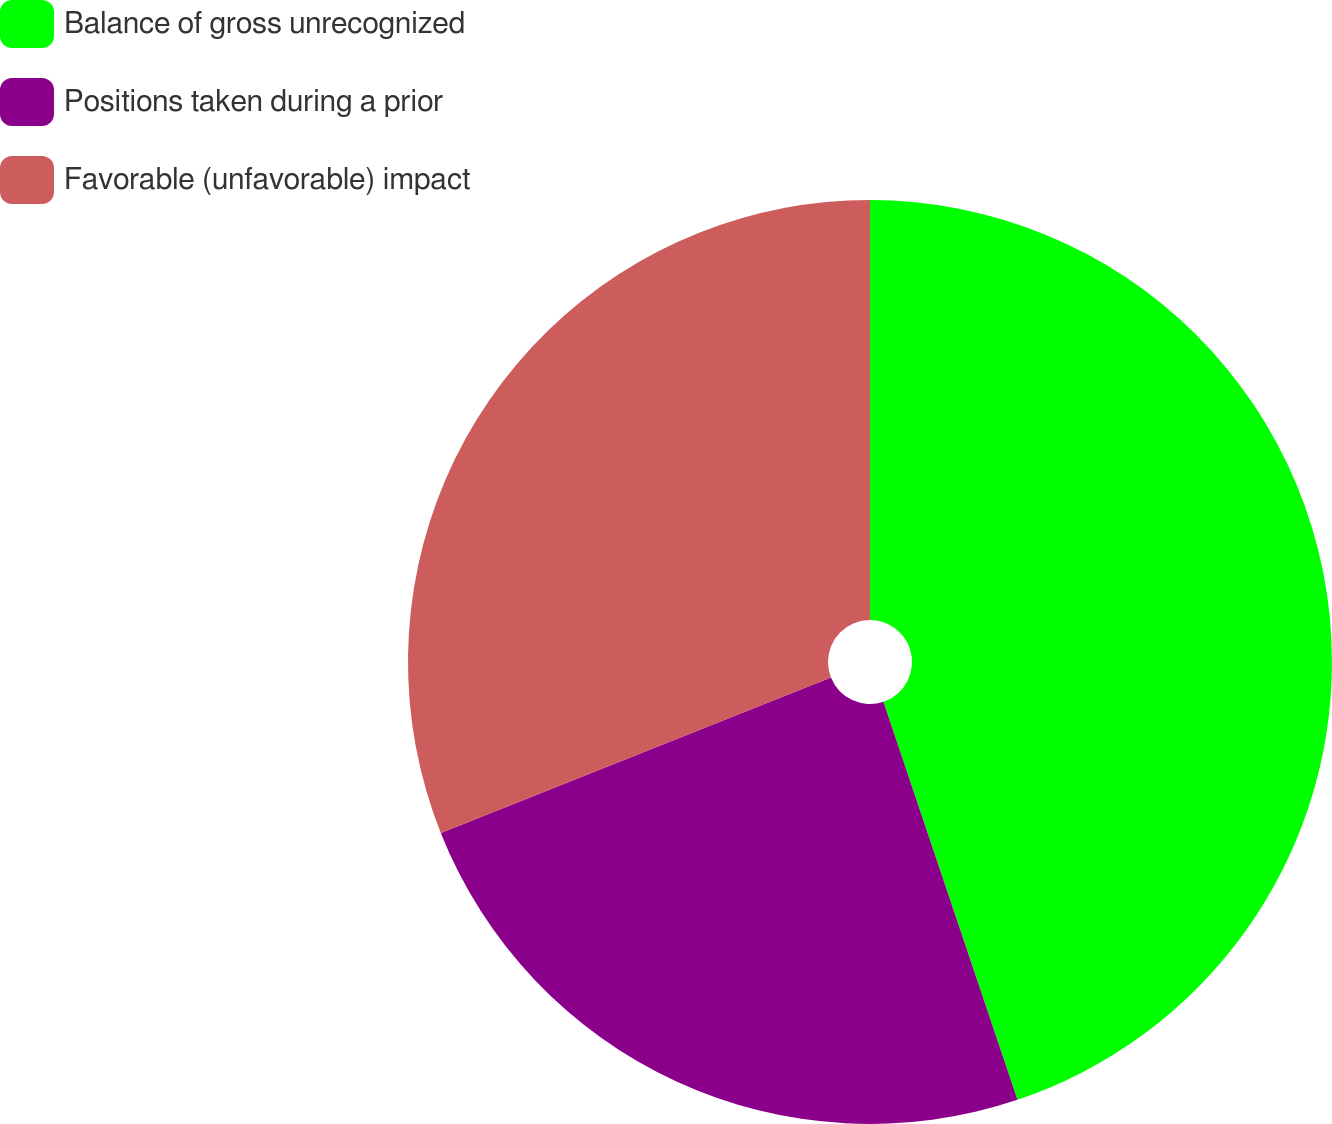Convert chart to OTSL. <chart><loc_0><loc_0><loc_500><loc_500><pie_chart><fcel>Balance of gross unrecognized<fcel>Positions taken during a prior<fcel>Favorable (unfavorable) impact<nl><fcel>44.83%<fcel>24.14%<fcel>31.03%<nl></chart> 